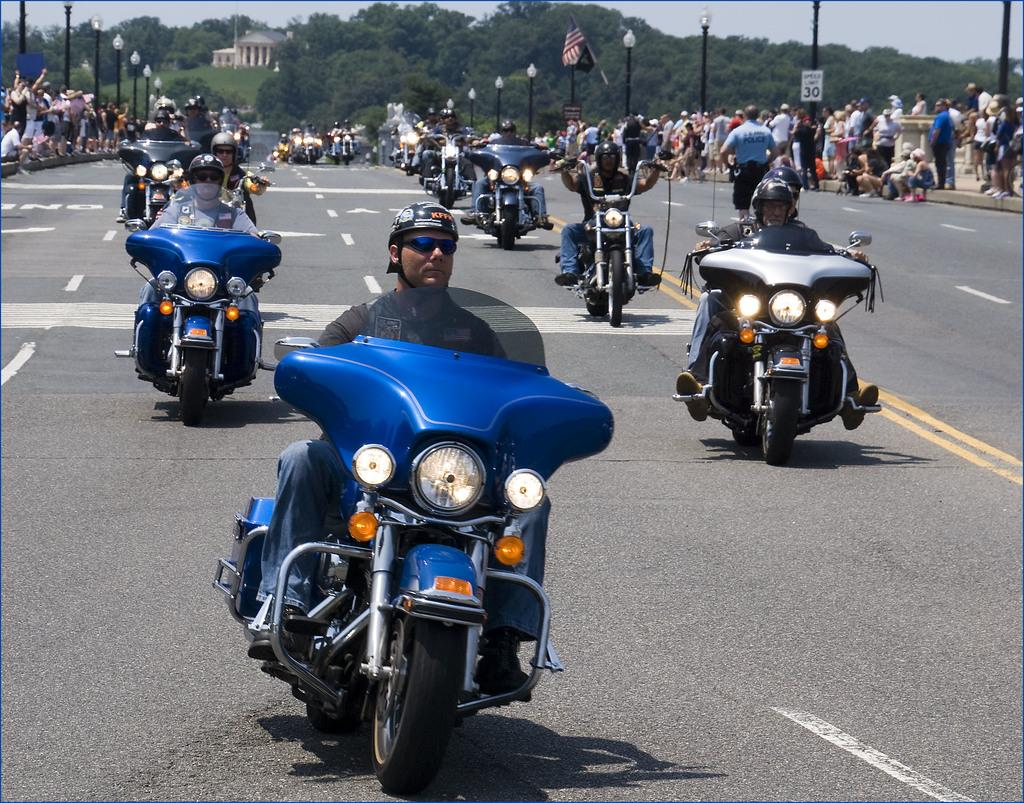What are the people in the image doing? The people in the image are riding bikes. What can be seen in the background of the image? There are trees, buildings, and poles in the background of the image. What is visible at the bottom of the image? There is a road visible at the bottom of the image. What type of milk is being produced by the grass in the image? There is no grass or milk production present in the image. What year is depicted in the image? The image does not depict a specific year; it is a timeless scene of people riding bikes. 